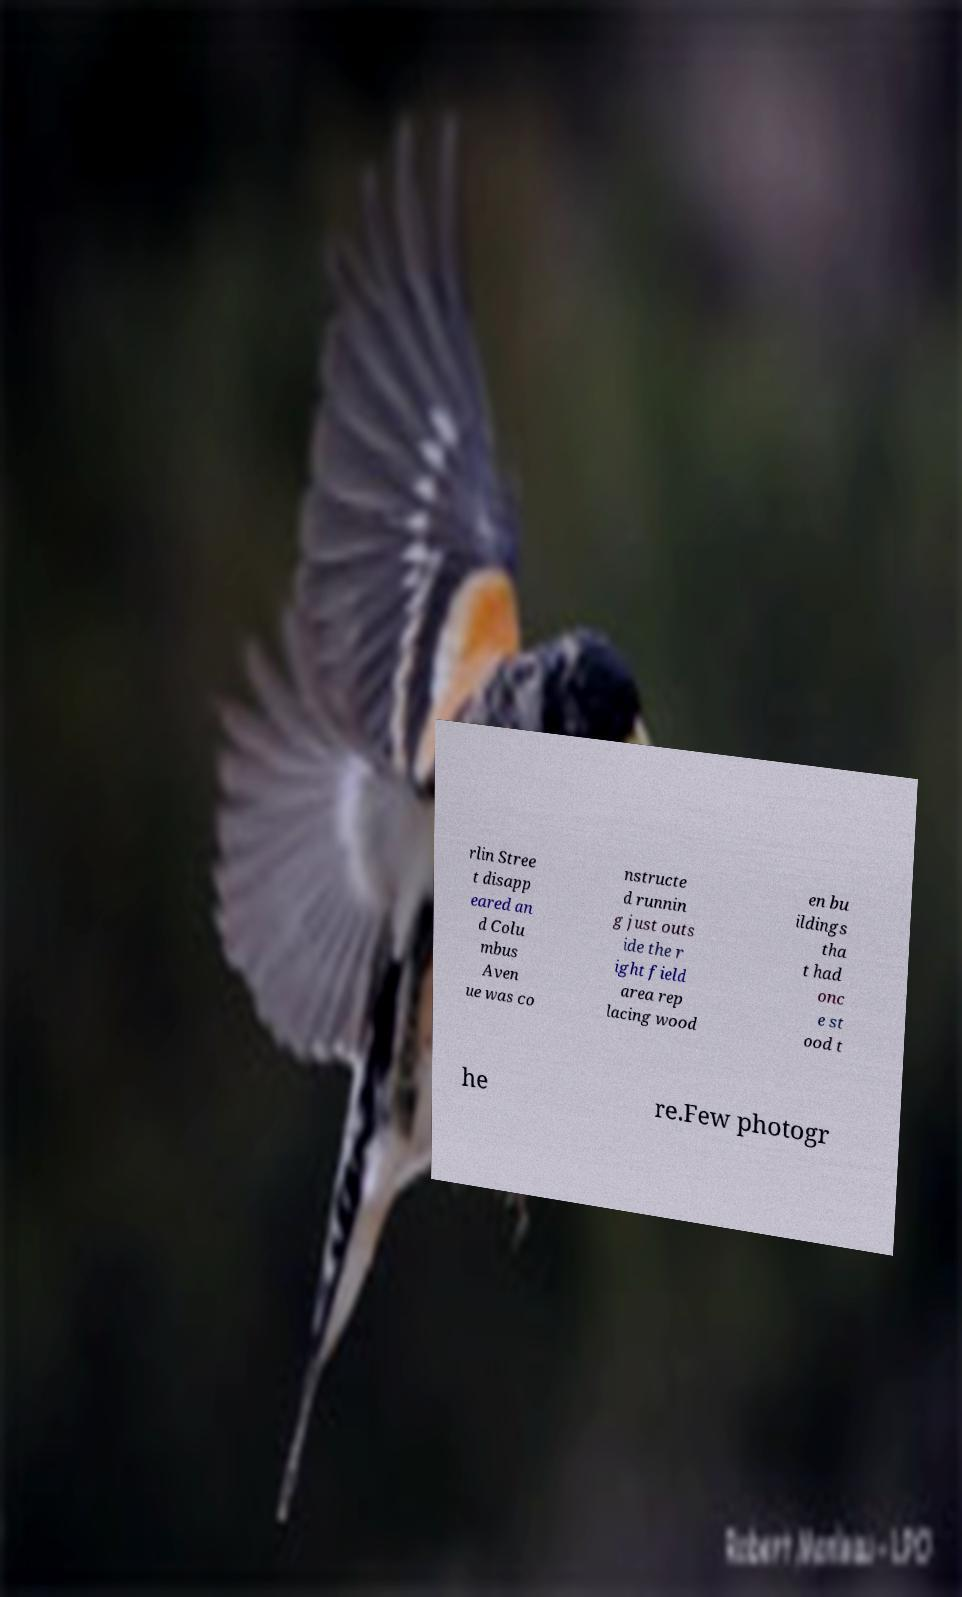Can you read and provide the text displayed in the image?This photo seems to have some interesting text. Can you extract and type it out for me? rlin Stree t disapp eared an d Colu mbus Aven ue was co nstructe d runnin g just outs ide the r ight field area rep lacing wood en bu ildings tha t had onc e st ood t he re.Few photogr 